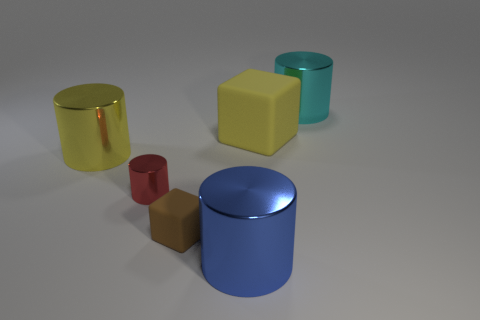How many other objects are there of the same color as the tiny block?
Your response must be concise. 0. What number of gray objects are small rubber blocks or cubes?
Keep it short and to the point. 0. What size is the yellow rubber cube?
Provide a succinct answer. Large. What number of rubber objects are either cyan cylinders or tiny objects?
Keep it short and to the point. 1. Are there fewer green metal blocks than yellow blocks?
Make the answer very short. Yes. How many other things are there of the same material as the tiny red object?
Keep it short and to the point. 3. There is a brown object that is the same shape as the large yellow rubber object; what size is it?
Provide a short and direct response. Small. Is the yellow object right of the small red metallic object made of the same material as the big object in front of the tiny brown cube?
Give a very brief answer. No. Is the number of large cyan shiny things that are behind the large cube less than the number of small balls?
Your answer should be compact. No. Is there any other thing that has the same shape as the brown matte object?
Give a very brief answer. Yes. 